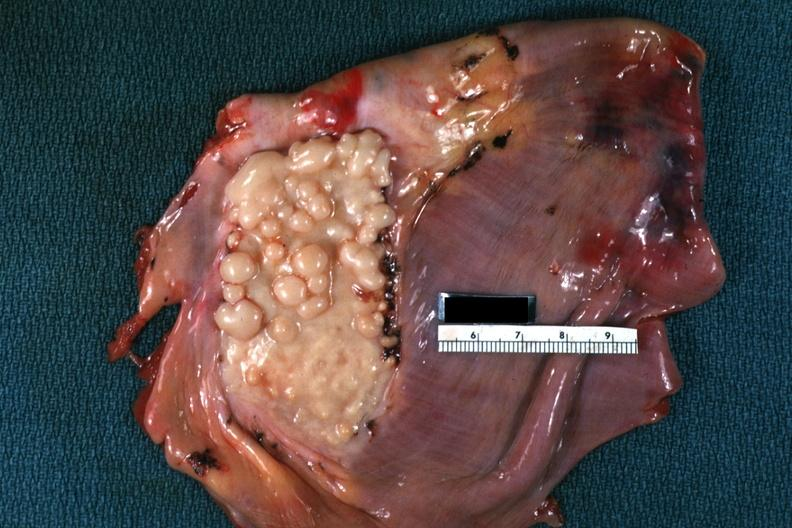what does this image show?
Answer the question using a single word or phrase. Plaque like lesion quite good 